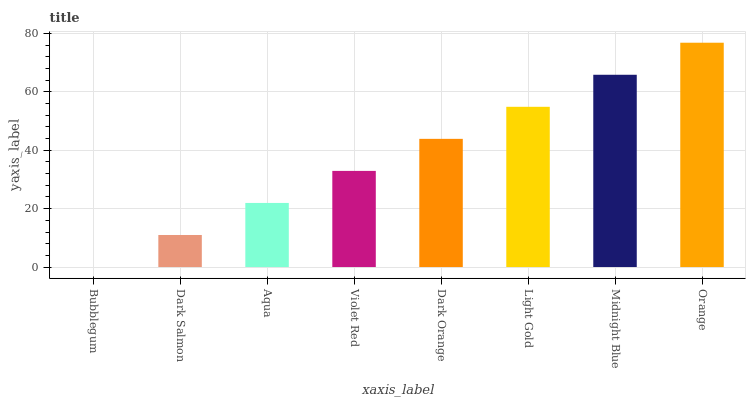Is Bubblegum the minimum?
Answer yes or no. Yes. Is Orange the maximum?
Answer yes or no. Yes. Is Dark Salmon the minimum?
Answer yes or no. No. Is Dark Salmon the maximum?
Answer yes or no. No. Is Dark Salmon greater than Bubblegum?
Answer yes or no. Yes. Is Bubblegum less than Dark Salmon?
Answer yes or no. Yes. Is Bubblegum greater than Dark Salmon?
Answer yes or no. No. Is Dark Salmon less than Bubblegum?
Answer yes or no. No. Is Dark Orange the high median?
Answer yes or no. Yes. Is Violet Red the low median?
Answer yes or no. Yes. Is Orange the high median?
Answer yes or no. No. Is Midnight Blue the low median?
Answer yes or no. No. 